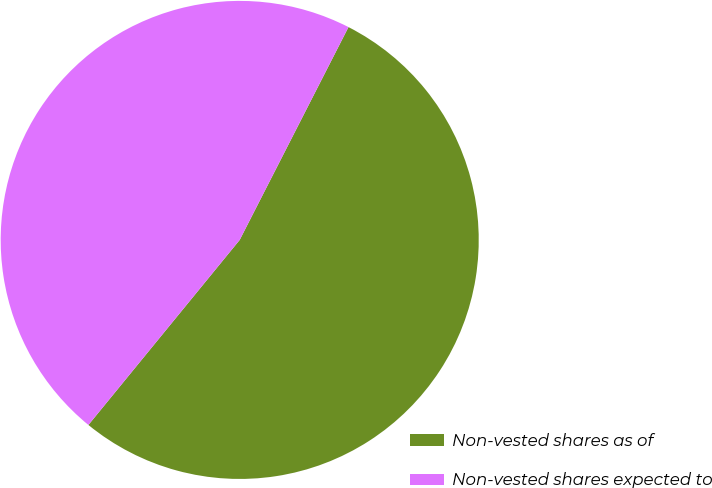<chart> <loc_0><loc_0><loc_500><loc_500><pie_chart><fcel>Non-vested shares as of<fcel>Non-vested shares expected to<nl><fcel>53.39%<fcel>46.61%<nl></chart> 